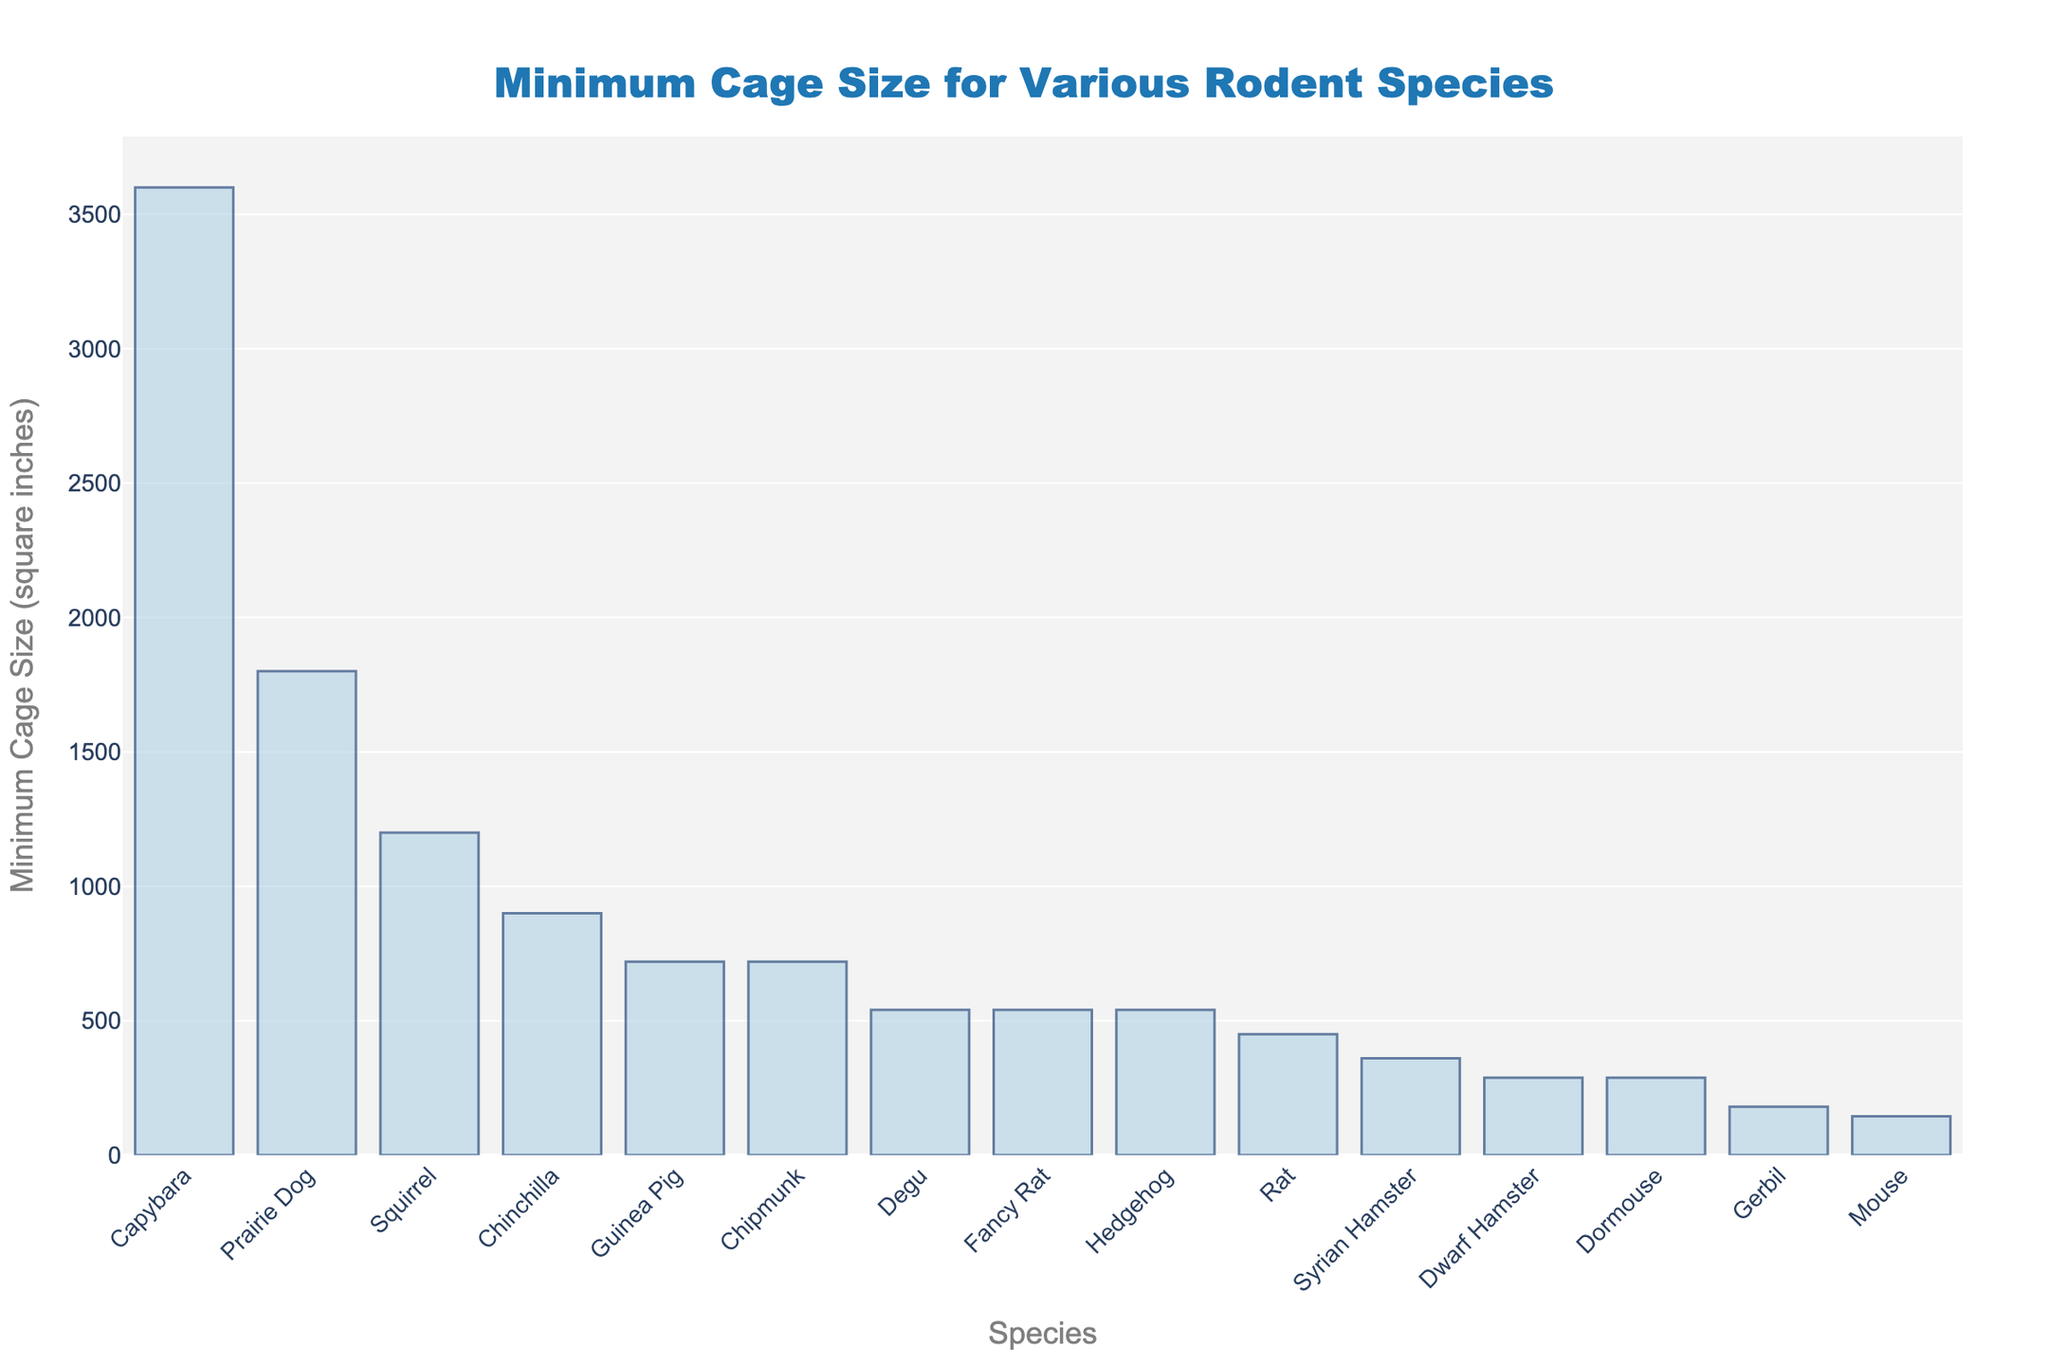Which species requires the largest minimum cage size? Looking at the bar chart, the species with the tallest bar corresponds to the largest minimum cage size. The Capybara's bar is the tallest.
Answer: Capybara Which rodent species requires a smaller cage size: Degu or Guinea Pig? In the chart, compare the heights of the bars for Degu and Guinea Pig. The Degu bar is shorter than the Guinea Pig bar.
Answer: Degu What is the difference in cage size requirements between a Rat and a Syrian Hamster? Find the bars for Rat and Syrian Hamster on the chart. The Rat requires 450 square inches, and the Syrian Hamster requires 360 square inches. The difference is 450 - 360.
Answer: 90 square inches Which two species have the same minimum cage size requirement of 288 square inches? Look at the chart for bars of equal height corresponding to 288 square inches. Both Dwarf Hamster and Dormouse have bars of this height.
Answer: Dwarf Hamster and Dormouse What is the average minimum cage size required for a Capybara, Prairie Dog, and Chinchilla? Check the bar heights for Capybara (3600), Prairie Dog (1800), and Chinchilla (900). Add them and divide by 3. (3600 + 1800 + 900) / 3 = 5400 / 3.
Answer: 1800 square inches Which species has a cage size requirement closer to 540 square inches: Squirrel or Fancy Rat? Compare the bar heights for Squirrel (1200) and Fancy Rat (540). Fancy Rat's required cage size matches exactly at 540 square inches.
Answer: Fancy Rat How many species require a minimum cage size of fewer than 300 square inches? Count the bars with heights representing values less than 300 square inches: Dwarf Hamster (288), Gerbil (180), Mouse (144), Dormouse (288).
Answer: 4 species What is the total minimum cage size required for both Chipmunk and Hedgehog? Find the bars for Chipmunk (720) and Hedgehog (540). Add these values together (720 + 540).
Answer: 1260 square inches If you were to combine the cage spaces of a Mouse and a Gerbil, would the total be more or less than a Rat's cage requirement? Check the bar heights for Mouse (144) and Gerbil (180). Summing these gives 144 + 180 = 324, which is less than the Rat's requirement (450).
Answer: Less What is the median value of the minimum cage sizes for all species? List all minimum cage sizes and order them: 144, 180, 288, 288, 360, 450, 540, 540, 720, 720, 900, 1200, 1800, 3600. The middle values are 540 and 540; the median is the average of these.
Answer: 540 square inches 